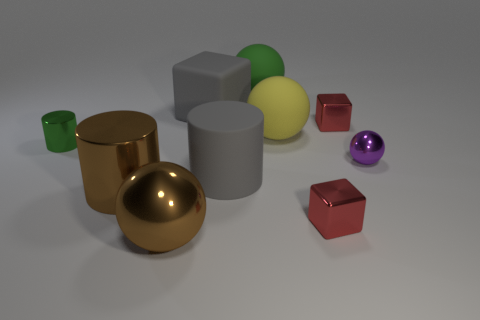Are there any metallic cylinders?
Provide a succinct answer. Yes. Is the big ball to the right of the green rubber thing made of the same material as the gray object behind the tiny metallic sphere?
Your answer should be very brief. Yes. There is a gray cylinder in front of the metal cylinder behind the large metallic thing that is on the left side of the big brown shiny sphere; what is its size?
Offer a terse response. Large. What number of red cubes have the same material as the brown cylinder?
Keep it short and to the point. 2. Is the number of yellow balls less than the number of big brown metal things?
Offer a very short reply. Yes. There is a gray object that is the same shape as the small green thing; what is its size?
Ensure brevity in your answer.  Large. Is the material of the red cube that is in front of the small ball the same as the green ball?
Offer a very short reply. No. Do the small purple shiny object and the large green object have the same shape?
Offer a terse response. Yes. How many objects are small cubes that are in front of the small metal sphere or big blue blocks?
Ensure brevity in your answer.  1. There is a brown object that is the same material as the brown cylinder; what is its size?
Ensure brevity in your answer.  Large. 